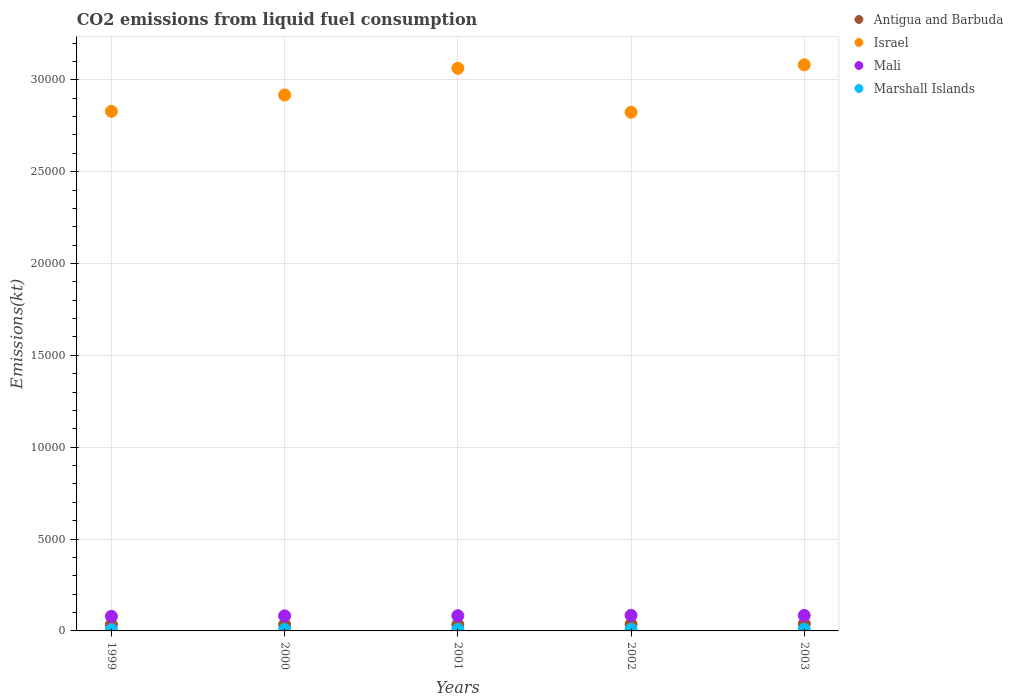Is the number of dotlines equal to the number of legend labels?
Provide a short and direct response. Yes. What is the amount of CO2 emitted in Antigua and Barbuda in 2000?
Keep it short and to the point. 344.7. Across all years, what is the maximum amount of CO2 emitted in Israel?
Your answer should be compact. 3.08e+04. Across all years, what is the minimum amount of CO2 emitted in Marshall Islands?
Make the answer very short. 66.01. In which year was the amount of CO2 emitted in Israel maximum?
Provide a succinct answer. 2003. In which year was the amount of CO2 emitted in Mali minimum?
Make the answer very short. 1999. What is the total amount of CO2 emitted in Antigua and Barbuda in the graph?
Keep it short and to the point. 1789.5. What is the difference between the amount of CO2 emitted in Antigua and Barbuda in 1999 and that in 2000?
Keep it short and to the point. 3.67. What is the difference between the amount of CO2 emitted in Mali in 2003 and the amount of CO2 emitted in Antigua and Barbuda in 2000?
Offer a very short reply. 498.71. What is the average amount of CO2 emitted in Antigua and Barbuda per year?
Provide a succinct answer. 357.9. In the year 2003, what is the difference between the amount of CO2 emitted in Israel and amount of CO2 emitted in Marshall Islands?
Give a very brief answer. 3.07e+04. In how many years, is the amount of CO2 emitted in Antigua and Barbuda greater than 15000 kt?
Give a very brief answer. 0. What is the ratio of the amount of CO2 emitted in Antigua and Barbuda in 1999 to that in 2002?
Give a very brief answer. 0.96. What is the difference between the highest and the second highest amount of CO2 emitted in Marshall Islands?
Your response must be concise. 0. What is the difference between the highest and the lowest amount of CO2 emitted in Antigua and Barbuda?
Give a very brief answer. 44. In how many years, is the amount of CO2 emitted in Mali greater than the average amount of CO2 emitted in Mali taken over all years?
Provide a short and direct response. 3. Is the sum of the amount of CO2 emitted in Mali in 1999 and 2003 greater than the maximum amount of CO2 emitted in Marshall Islands across all years?
Make the answer very short. Yes. Is it the case that in every year, the sum of the amount of CO2 emitted in Marshall Islands and amount of CO2 emitted in Antigua and Barbuda  is greater than the amount of CO2 emitted in Mali?
Offer a terse response. No. Is the amount of CO2 emitted in Mali strictly greater than the amount of CO2 emitted in Marshall Islands over the years?
Make the answer very short. Yes. Is the amount of CO2 emitted in Antigua and Barbuda strictly less than the amount of CO2 emitted in Marshall Islands over the years?
Make the answer very short. No. How many dotlines are there?
Provide a succinct answer. 4. Does the graph contain grids?
Offer a terse response. Yes. Where does the legend appear in the graph?
Ensure brevity in your answer.  Top right. How many legend labels are there?
Provide a short and direct response. 4. What is the title of the graph?
Offer a very short reply. CO2 emissions from liquid fuel consumption. Does "Cabo Verde" appear as one of the legend labels in the graph?
Offer a very short reply. No. What is the label or title of the Y-axis?
Make the answer very short. Emissions(kt). What is the Emissions(kt) of Antigua and Barbuda in 1999?
Offer a terse response. 348.37. What is the Emissions(kt) of Israel in 1999?
Your answer should be very brief. 2.83e+04. What is the Emissions(kt) of Mali in 1999?
Provide a short and direct response. 795.74. What is the Emissions(kt) of Marshall Islands in 1999?
Offer a terse response. 66.01. What is the Emissions(kt) in Antigua and Barbuda in 2000?
Offer a very short reply. 344.7. What is the Emissions(kt) in Israel in 2000?
Ensure brevity in your answer.  2.92e+04. What is the Emissions(kt) of Mali in 2000?
Provide a short and direct response. 821.41. What is the Emissions(kt) of Marshall Islands in 2000?
Keep it short and to the point. 77.01. What is the Emissions(kt) in Antigua and Barbuda in 2001?
Ensure brevity in your answer.  344.7. What is the Emissions(kt) of Israel in 2001?
Keep it short and to the point. 3.06e+04. What is the Emissions(kt) in Mali in 2001?
Offer a very short reply. 828.74. What is the Emissions(kt) in Marshall Islands in 2001?
Ensure brevity in your answer.  80.67. What is the Emissions(kt) in Antigua and Barbuda in 2002?
Your answer should be compact. 363.03. What is the Emissions(kt) of Israel in 2002?
Ensure brevity in your answer.  2.82e+04. What is the Emissions(kt) in Mali in 2002?
Ensure brevity in your answer.  847.08. What is the Emissions(kt) of Marshall Islands in 2002?
Provide a succinct answer. 84.34. What is the Emissions(kt) in Antigua and Barbuda in 2003?
Your response must be concise. 388.7. What is the Emissions(kt) in Israel in 2003?
Keep it short and to the point. 3.08e+04. What is the Emissions(kt) in Mali in 2003?
Ensure brevity in your answer.  843.41. What is the Emissions(kt) of Marshall Islands in 2003?
Give a very brief answer. 84.34. Across all years, what is the maximum Emissions(kt) in Antigua and Barbuda?
Provide a succinct answer. 388.7. Across all years, what is the maximum Emissions(kt) of Israel?
Provide a short and direct response. 3.08e+04. Across all years, what is the maximum Emissions(kt) in Mali?
Your answer should be compact. 847.08. Across all years, what is the maximum Emissions(kt) in Marshall Islands?
Make the answer very short. 84.34. Across all years, what is the minimum Emissions(kt) in Antigua and Barbuda?
Provide a short and direct response. 344.7. Across all years, what is the minimum Emissions(kt) in Israel?
Make the answer very short. 2.82e+04. Across all years, what is the minimum Emissions(kt) of Mali?
Offer a very short reply. 795.74. Across all years, what is the minimum Emissions(kt) in Marshall Islands?
Offer a terse response. 66.01. What is the total Emissions(kt) of Antigua and Barbuda in the graph?
Ensure brevity in your answer.  1789.5. What is the total Emissions(kt) of Israel in the graph?
Your answer should be compact. 1.47e+05. What is the total Emissions(kt) in Mali in the graph?
Offer a very short reply. 4136.38. What is the total Emissions(kt) of Marshall Islands in the graph?
Give a very brief answer. 392.37. What is the difference between the Emissions(kt) in Antigua and Barbuda in 1999 and that in 2000?
Give a very brief answer. 3.67. What is the difference between the Emissions(kt) of Israel in 1999 and that in 2000?
Ensure brevity in your answer.  -891.08. What is the difference between the Emissions(kt) of Mali in 1999 and that in 2000?
Your answer should be compact. -25.67. What is the difference between the Emissions(kt) in Marshall Islands in 1999 and that in 2000?
Provide a short and direct response. -11. What is the difference between the Emissions(kt) in Antigua and Barbuda in 1999 and that in 2001?
Offer a terse response. 3.67. What is the difference between the Emissions(kt) in Israel in 1999 and that in 2001?
Offer a terse response. -2346.88. What is the difference between the Emissions(kt) of Mali in 1999 and that in 2001?
Give a very brief answer. -33. What is the difference between the Emissions(kt) in Marshall Islands in 1999 and that in 2001?
Give a very brief answer. -14.67. What is the difference between the Emissions(kt) of Antigua and Barbuda in 1999 and that in 2002?
Offer a very short reply. -14.67. What is the difference between the Emissions(kt) of Israel in 1999 and that in 2002?
Make the answer very short. 47.67. What is the difference between the Emissions(kt) of Mali in 1999 and that in 2002?
Your answer should be very brief. -51.34. What is the difference between the Emissions(kt) in Marshall Islands in 1999 and that in 2002?
Keep it short and to the point. -18.34. What is the difference between the Emissions(kt) of Antigua and Barbuda in 1999 and that in 2003?
Your response must be concise. -40.34. What is the difference between the Emissions(kt) in Israel in 1999 and that in 2003?
Give a very brief answer. -2533.9. What is the difference between the Emissions(kt) of Mali in 1999 and that in 2003?
Provide a short and direct response. -47.67. What is the difference between the Emissions(kt) in Marshall Islands in 1999 and that in 2003?
Give a very brief answer. -18.34. What is the difference between the Emissions(kt) in Antigua and Barbuda in 2000 and that in 2001?
Give a very brief answer. 0. What is the difference between the Emissions(kt) in Israel in 2000 and that in 2001?
Your answer should be compact. -1455.8. What is the difference between the Emissions(kt) of Mali in 2000 and that in 2001?
Ensure brevity in your answer.  -7.33. What is the difference between the Emissions(kt) of Marshall Islands in 2000 and that in 2001?
Keep it short and to the point. -3.67. What is the difference between the Emissions(kt) in Antigua and Barbuda in 2000 and that in 2002?
Offer a terse response. -18.34. What is the difference between the Emissions(kt) of Israel in 2000 and that in 2002?
Offer a very short reply. 938.75. What is the difference between the Emissions(kt) of Mali in 2000 and that in 2002?
Offer a terse response. -25.67. What is the difference between the Emissions(kt) in Marshall Islands in 2000 and that in 2002?
Keep it short and to the point. -7.33. What is the difference between the Emissions(kt) in Antigua and Barbuda in 2000 and that in 2003?
Keep it short and to the point. -44. What is the difference between the Emissions(kt) of Israel in 2000 and that in 2003?
Provide a succinct answer. -1642.82. What is the difference between the Emissions(kt) in Mali in 2000 and that in 2003?
Make the answer very short. -22. What is the difference between the Emissions(kt) in Marshall Islands in 2000 and that in 2003?
Give a very brief answer. -7.33. What is the difference between the Emissions(kt) of Antigua and Barbuda in 2001 and that in 2002?
Offer a terse response. -18.34. What is the difference between the Emissions(kt) of Israel in 2001 and that in 2002?
Give a very brief answer. 2394.55. What is the difference between the Emissions(kt) in Mali in 2001 and that in 2002?
Give a very brief answer. -18.34. What is the difference between the Emissions(kt) of Marshall Islands in 2001 and that in 2002?
Ensure brevity in your answer.  -3.67. What is the difference between the Emissions(kt) in Antigua and Barbuda in 2001 and that in 2003?
Offer a terse response. -44. What is the difference between the Emissions(kt) in Israel in 2001 and that in 2003?
Give a very brief answer. -187.02. What is the difference between the Emissions(kt) of Mali in 2001 and that in 2003?
Make the answer very short. -14.67. What is the difference between the Emissions(kt) of Marshall Islands in 2001 and that in 2003?
Provide a short and direct response. -3.67. What is the difference between the Emissions(kt) in Antigua and Barbuda in 2002 and that in 2003?
Keep it short and to the point. -25.67. What is the difference between the Emissions(kt) of Israel in 2002 and that in 2003?
Ensure brevity in your answer.  -2581.57. What is the difference between the Emissions(kt) in Mali in 2002 and that in 2003?
Your response must be concise. 3.67. What is the difference between the Emissions(kt) in Antigua and Barbuda in 1999 and the Emissions(kt) in Israel in 2000?
Offer a very short reply. -2.88e+04. What is the difference between the Emissions(kt) of Antigua and Barbuda in 1999 and the Emissions(kt) of Mali in 2000?
Make the answer very short. -473.04. What is the difference between the Emissions(kt) in Antigua and Barbuda in 1999 and the Emissions(kt) in Marshall Islands in 2000?
Offer a very short reply. 271.36. What is the difference between the Emissions(kt) of Israel in 1999 and the Emissions(kt) of Mali in 2000?
Offer a terse response. 2.75e+04. What is the difference between the Emissions(kt) of Israel in 1999 and the Emissions(kt) of Marshall Islands in 2000?
Offer a very short reply. 2.82e+04. What is the difference between the Emissions(kt) in Mali in 1999 and the Emissions(kt) in Marshall Islands in 2000?
Keep it short and to the point. 718.73. What is the difference between the Emissions(kt) in Antigua and Barbuda in 1999 and the Emissions(kt) in Israel in 2001?
Give a very brief answer. -3.03e+04. What is the difference between the Emissions(kt) of Antigua and Barbuda in 1999 and the Emissions(kt) of Mali in 2001?
Offer a terse response. -480.38. What is the difference between the Emissions(kt) of Antigua and Barbuda in 1999 and the Emissions(kt) of Marshall Islands in 2001?
Make the answer very short. 267.69. What is the difference between the Emissions(kt) in Israel in 1999 and the Emissions(kt) in Mali in 2001?
Provide a short and direct response. 2.75e+04. What is the difference between the Emissions(kt) of Israel in 1999 and the Emissions(kt) of Marshall Islands in 2001?
Your response must be concise. 2.82e+04. What is the difference between the Emissions(kt) in Mali in 1999 and the Emissions(kt) in Marshall Islands in 2001?
Offer a terse response. 715.07. What is the difference between the Emissions(kt) of Antigua and Barbuda in 1999 and the Emissions(kt) of Israel in 2002?
Make the answer very short. -2.79e+04. What is the difference between the Emissions(kt) of Antigua and Barbuda in 1999 and the Emissions(kt) of Mali in 2002?
Give a very brief answer. -498.71. What is the difference between the Emissions(kt) in Antigua and Barbuda in 1999 and the Emissions(kt) in Marshall Islands in 2002?
Provide a short and direct response. 264.02. What is the difference between the Emissions(kt) of Israel in 1999 and the Emissions(kt) of Mali in 2002?
Offer a terse response. 2.74e+04. What is the difference between the Emissions(kt) in Israel in 1999 and the Emissions(kt) in Marshall Islands in 2002?
Offer a terse response. 2.82e+04. What is the difference between the Emissions(kt) in Mali in 1999 and the Emissions(kt) in Marshall Islands in 2002?
Keep it short and to the point. 711.4. What is the difference between the Emissions(kt) of Antigua and Barbuda in 1999 and the Emissions(kt) of Israel in 2003?
Make the answer very short. -3.05e+04. What is the difference between the Emissions(kt) in Antigua and Barbuda in 1999 and the Emissions(kt) in Mali in 2003?
Your answer should be compact. -495.05. What is the difference between the Emissions(kt) in Antigua and Barbuda in 1999 and the Emissions(kt) in Marshall Islands in 2003?
Keep it short and to the point. 264.02. What is the difference between the Emissions(kt) of Israel in 1999 and the Emissions(kt) of Mali in 2003?
Offer a terse response. 2.74e+04. What is the difference between the Emissions(kt) in Israel in 1999 and the Emissions(kt) in Marshall Islands in 2003?
Ensure brevity in your answer.  2.82e+04. What is the difference between the Emissions(kt) in Mali in 1999 and the Emissions(kt) in Marshall Islands in 2003?
Make the answer very short. 711.4. What is the difference between the Emissions(kt) of Antigua and Barbuda in 2000 and the Emissions(kt) of Israel in 2001?
Offer a terse response. -3.03e+04. What is the difference between the Emissions(kt) of Antigua and Barbuda in 2000 and the Emissions(kt) of Mali in 2001?
Provide a short and direct response. -484.04. What is the difference between the Emissions(kt) in Antigua and Barbuda in 2000 and the Emissions(kt) in Marshall Islands in 2001?
Ensure brevity in your answer.  264.02. What is the difference between the Emissions(kt) in Israel in 2000 and the Emissions(kt) in Mali in 2001?
Provide a short and direct response. 2.83e+04. What is the difference between the Emissions(kt) of Israel in 2000 and the Emissions(kt) of Marshall Islands in 2001?
Your response must be concise. 2.91e+04. What is the difference between the Emissions(kt) of Mali in 2000 and the Emissions(kt) of Marshall Islands in 2001?
Offer a very short reply. 740.73. What is the difference between the Emissions(kt) of Antigua and Barbuda in 2000 and the Emissions(kt) of Israel in 2002?
Provide a succinct answer. -2.79e+04. What is the difference between the Emissions(kt) of Antigua and Barbuda in 2000 and the Emissions(kt) of Mali in 2002?
Ensure brevity in your answer.  -502.38. What is the difference between the Emissions(kt) in Antigua and Barbuda in 2000 and the Emissions(kt) in Marshall Islands in 2002?
Keep it short and to the point. 260.36. What is the difference between the Emissions(kt) of Israel in 2000 and the Emissions(kt) of Mali in 2002?
Offer a terse response. 2.83e+04. What is the difference between the Emissions(kt) of Israel in 2000 and the Emissions(kt) of Marshall Islands in 2002?
Provide a short and direct response. 2.91e+04. What is the difference between the Emissions(kt) in Mali in 2000 and the Emissions(kt) in Marshall Islands in 2002?
Your response must be concise. 737.07. What is the difference between the Emissions(kt) of Antigua and Barbuda in 2000 and the Emissions(kt) of Israel in 2003?
Make the answer very short. -3.05e+04. What is the difference between the Emissions(kt) in Antigua and Barbuda in 2000 and the Emissions(kt) in Mali in 2003?
Ensure brevity in your answer.  -498.71. What is the difference between the Emissions(kt) of Antigua and Barbuda in 2000 and the Emissions(kt) of Marshall Islands in 2003?
Your answer should be very brief. 260.36. What is the difference between the Emissions(kt) in Israel in 2000 and the Emissions(kt) in Mali in 2003?
Your response must be concise. 2.83e+04. What is the difference between the Emissions(kt) of Israel in 2000 and the Emissions(kt) of Marshall Islands in 2003?
Make the answer very short. 2.91e+04. What is the difference between the Emissions(kt) of Mali in 2000 and the Emissions(kt) of Marshall Islands in 2003?
Keep it short and to the point. 737.07. What is the difference between the Emissions(kt) of Antigua and Barbuda in 2001 and the Emissions(kt) of Israel in 2002?
Offer a very short reply. -2.79e+04. What is the difference between the Emissions(kt) of Antigua and Barbuda in 2001 and the Emissions(kt) of Mali in 2002?
Provide a short and direct response. -502.38. What is the difference between the Emissions(kt) in Antigua and Barbuda in 2001 and the Emissions(kt) in Marshall Islands in 2002?
Provide a short and direct response. 260.36. What is the difference between the Emissions(kt) of Israel in 2001 and the Emissions(kt) of Mali in 2002?
Keep it short and to the point. 2.98e+04. What is the difference between the Emissions(kt) in Israel in 2001 and the Emissions(kt) in Marshall Islands in 2002?
Offer a terse response. 3.05e+04. What is the difference between the Emissions(kt) of Mali in 2001 and the Emissions(kt) of Marshall Islands in 2002?
Your answer should be very brief. 744.4. What is the difference between the Emissions(kt) of Antigua and Barbuda in 2001 and the Emissions(kt) of Israel in 2003?
Provide a succinct answer. -3.05e+04. What is the difference between the Emissions(kt) in Antigua and Barbuda in 2001 and the Emissions(kt) in Mali in 2003?
Provide a succinct answer. -498.71. What is the difference between the Emissions(kt) of Antigua and Barbuda in 2001 and the Emissions(kt) of Marshall Islands in 2003?
Ensure brevity in your answer.  260.36. What is the difference between the Emissions(kt) of Israel in 2001 and the Emissions(kt) of Mali in 2003?
Your answer should be very brief. 2.98e+04. What is the difference between the Emissions(kt) in Israel in 2001 and the Emissions(kt) in Marshall Islands in 2003?
Your response must be concise. 3.05e+04. What is the difference between the Emissions(kt) in Mali in 2001 and the Emissions(kt) in Marshall Islands in 2003?
Give a very brief answer. 744.4. What is the difference between the Emissions(kt) in Antigua and Barbuda in 2002 and the Emissions(kt) in Israel in 2003?
Ensure brevity in your answer.  -3.05e+04. What is the difference between the Emissions(kt) of Antigua and Barbuda in 2002 and the Emissions(kt) of Mali in 2003?
Keep it short and to the point. -480.38. What is the difference between the Emissions(kt) of Antigua and Barbuda in 2002 and the Emissions(kt) of Marshall Islands in 2003?
Give a very brief answer. 278.69. What is the difference between the Emissions(kt) of Israel in 2002 and the Emissions(kt) of Mali in 2003?
Offer a very short reply. 2.74e+04. What is the difference between the Emissions(kt) in Israel in 2002 and the Emissions(kt) in Marshall Islands in 2003?
Provide a succinct answer. 2.81e+04. What is the difference between the Emissions(kt) of Mali in 2002 and the Emissions(kt) of Marshall Islands in 2003?
Offer a terse response. 762.74. What is the average Emissions(kt) of Antigua and Barbuda per year?
Your answer should be very brief. 357.9. What is the average Emissions(kt) of Israel per year?
Your answer should be very brief. 2.94e+04. What is the average Emissions(kt) of Mali per year?
Offer a terse response. 827.28. What is the average Emissions(kt) in Marshall Islands per year?
Your response must be concise. 78.47. In the year 1999, what is the difference between the Emissions(kt) of Antigua and Barbuda and Emissions(kt) of Israel?
Make the answer very short. -2.79e+04. In the year 1999, what is the difference between the Emissions(kt) of Antigua and Barbuda and Emissions(kt) of Mali?
Provide a succinct answer. -447.37. In the year 1999, what is the difference between the Emissions(kt) of Antigua and Barbuda and Emissions(kt) of Marshall Islands?
Give a very brief answer. 282.36. In the year 1999, what is the difference between the Emissions(kt) of Israel and Emissions(kt) of Mali?
Ensure brevity in your answer.  2.75e+04. In the year 1999, what is the difference between the Emissions(kt) of Israel and Emissions(kt) of Marshall Islands?
Your answer should be compact. 2.82e+04. In the year 1999, what is the difference between the Emissions(kt) of Mali and Emissions(kt) of Marshall Islands?
Make the answer very short. 729.73. In the year 2000, what is the difference between the Emissions(kt) of Antigua and Barbuda and Emissions(kt) of Israel?
Provide a succinct answer. -2.88e+04. In the year 2000, what is the difference between the Emissions(kt) in Antigua and Barbuda and Emissions(kt) in Mali?
Provide a short and direct response. -476.71. In the year 2000, what is the difference between the Emissions(kt) of Antigua and Barbuda and Emissions(kt) of Marshall Islands?
Your answer should be very brief. 267.69. In the year 2000, what is the difference between the Emissions(kt) in Israel and Emissions(kt) in Mali?
Give a very brief answer. 2.83e+04. In the year 2000, what is the difference between the Emissions(kt) in Israel and Emissions(kt) in Marshall Islands?
Keep it short and to the point. 2.91e+04. In the year 2000, what is the difference between the Emissions(kt) of Mali and Emissions(kt) of Marshall Islands?
Provide a succinct answer. 744.4. In the year 2001, what is the difference between the Emissions(kt) of Antigua and Barbuda and Emissions(kt) of Israel?
Offer a very short reply. -3.03e+04. In the year 2001, what is the difference between the Emissions(kt) in Antigua and Barbuda and Emissions(kt) in Mali?
Offer a terse response. -484.04. In the year 2001, what is the difference between the Emissions(kt) in Antigua and Barbuda and Emissions(kt) in Marshall Islands?
Make the answer very short. 264.02. In the year 2001, what is the difference between the Emissions(kt) of Israel and Emissions(kt) of Mali?
Keep it short and to the point. 2.98e+04. In the year 2001, what is the difference between the Emissions(kt) of Israel and Emissions(kt) of Marshall Islands?
Offer a very short reply. 3.05e+04. In the year 2001, what is the difference between the Emissions(kt) in Mali and Emissions(kt) in Marshall Islands?
Your response must be concise. 748.07. In the year 2002, what is the difference between the Emissions(kt) of Antigua and Barbuda and Emissions(kt) of Israel?
Give a very brief answer. -2.79e+04. In the year 2002, what is the difference between the Emissions(kt) in Antigua and Barbuda and Emissions(kt) in Mali?
Keep it short and to the point. -484.04. In the year 2002, what is the difference between the Emissions(kt) in Antigua and Barbuda and Emissions(kt) in Marshall Islands?
Offer a terse response. 278.69. In the year 2002, what is the difference between the Emissions(kt) in Israel and Emissions(kt) in Mali?
Provide a short and direct response. 2.74e+04. In the year 2002, what is the difference between the Emissions(kt) of Israel and Emissions(kt) of Marshall Islands?
Your response must be concise. 2.81e+04. In the year 2002, what is the difference between the Emissions(kt) of Mali and Emissions(kt) of Marshall Islands?
Ensure brevity in your answer.  762.74. In the year 2003, what is the difference between the Emissions(kt) in Antigua and Barbuda and Emissions(kt) in Israel?
Give a very brief answer. -3.04e+04. In the year 2003, what is the difference between the Emissions(kt) in Antigua and Barbuda and Emissions(kt) in Mali?
Offer a very short reply. -454.71. In the year 2003, what is the difference between the Emissions(kt) in Antigua and Barbuda and Emissions(kt) in Marshall Islands?
Your response must be concise. 304.36. In the year 2003, what is the difference between the Emissions(kt) of Israel and Emissions(kt) of Mali?
Make the answer very short. 3.00e+04. In the year 2003, what is the difference between the Emissions(kt) in Israel and Emissions(kt) in Marshall Islands?
Provide a succinct answer. 3.07e+04. In the year 2003, what is the difference between the Emissions(kt) of Mali and Emissions(kt) of Marshall Islands?
Provide a short and direct response. 759.07. What is the ratio of the Emissions(kt) of Antigua and Barbuda in 1999 to that in 2000?
Offer a terse response. 1.01. What is the ratio of the Emissions(kt) of Israel in 1999 to that in 2000?
Your response must be concise. 0.97. What is the ratio of the Emissions(kt) of Mali in 1999 to that in 2000?
Keep it short and to the point. 0.97. What is the ratio of the Emissions(kt) of Marshall Islands in 1999 to that in 2000?
Make the answer very short. 0.86. What is the ratio of the Emissions(kt) of Antigua and Barbuda in 1999 to that in 2001?
Give a very brief answer. 1.01. What is the ratio of the Emissions(kt) of Israel in 1999 to that in 2001?
Keep it short and to the point. 0.92. What is the ratio of the Emissions(kt) in Mali in 1999 to that in 2001?
Your answer should be very brief. 0.96. What is the ratio of the Emissions(kt) of Marshall Islands in 1999 to that in 2001?
Your answer should be compact. 0.82. What is the ratio of the Emissions(kt) in Antigua and Barbuda in 1999 to that in 2002?
Your response must be concise. 0.96. What is the ratio of the Emissions(kt) in Mali in 1999 to that in 2002?
Make the answer very short. 0.94. What is the ratio of the Emissions(kt) in Marshall Islands in 1999 to that in 2002?
Ensure brevity in your answer.  0.78. What is the ratio of the Emissions(kt) in Antigua and Barbuda in 1999 to that in 2003?
Your answer should be very brief. 0.9. What is the ratio of the Emissions(kt) of Israel in 1999 to that in 2003?
Offer a terse response. 0.92. What is the ratio of the Emissions(kt) of Mali in 1999 to that in 2003?
Keep it short and to the point. 0.94. What is the ratio of the Emissions(kt) in Marshall Islands in 1999 to that in 2003?
Make the answer very short. 0.78. What is the ratio of the Emissions(kt) in Israel in 2000 to that in 2001?
Your answer should be very brief. 0.95. What is the ratio of the Emissions(kt) in Mali in 2000 to that in 2001?
Provide a short and direct response. 0.99. What is the ratio of the Emissions(kt) in Marshall Islands in 2000 to that in 2001?
Offer a terse response. 0.95. What is the ratio of the Emissions(kt) in Antigua and Barbuda in 2000 to that in 2002?
Your answer should be compact. 0.95. What is the ratio of the Emissions(kt) of Mali in 2000 to that in 2002?
Give a very brief answer. 0.97. What is the ratio of the Emissions(kt) of Marshall Islands in 2000 to that in 2002?
Offer a very short reply. 0.91. What is the ratio of the Emissions(kt) of Antigua and Barbuda in 2000 to that in 2003?
Make the answer very short. 0.89. What is the ratio of the Emissions(kt) of Israel in 2000 to that in 2003?
Offer a terse response. 0.95. What is the ratio of the Emissions(kt) of Mali in 2000 to that in 2003?
Offer a very short reply. 0.97. What is the ratio of the Emissions(kt) in Marshall Islands in 2000 to that in 2003?
Keep it short and to the point. 0.91. What is the ratio of the Emissions(kt) of Antigua and Barbuda in 2001 to that in 2002?
Provide a succinct answer. 0.95. What is the ratio of the Emissions(kt) of Israel in 2001 to that in 2002?
Keep it short and to the point. 1.08. What is the ratio of the Emissions(kt) of Mali in 2001 to that in 2002?
Offer a very short reply. 0.98. What is the ratio of the Emissions(kt) of Marshall Islands in 2001 to that in 2002?
Your response must be concise. 0.96. What is the ratio of the Emissions(kt) of Antigua and Barbuda in 2001 to that in 2003?
Offer a terse response. 0.89. What is the ratio of the Emissions(kt) in Mali in 2001 to that in 2003?
Your answer should be compact. 0.98. What is the ratio of the Emissions(kt) in Marshall Islands in 2001 to that in 2003?
Ensure brevity in your answer.  0.96. What is the ratio of the Emissions(kt) of Antigua and Barbuda in 2002 to that in 2003?
Your answer should be very brief. 0.93. What is the ratio of the Emissions(kt) in Israel in 2002 to that in 2003?
Offer a terse response. 0.92. What is the ratio of the Emissions(kt) of Mali in 2002 to that in 2003?
Your response must be concise. 1. What is the ratio of the Emissions(kt) of Marshall Islands in 2002 to that in 2003?
Offer a very short reply. 1. What is the difference between the highest and the second highest Emissions(kt) of Antigua and Barbuda?
Offer a terse response. 25.67. What is the difference between the highest and the second highest Emissions(kt) in Israel?
Give a very brief answer. 187.02. What is the difference between the highest and the second highest Emissions(kt) in Mali?
Keep it short and to the point. 3.67. What is the difference between the highest and the lowest Emissions(kt) in Antigua and Barbuda?
Your answer should be compact. 44. What is the difference between the highest and the lowest Emissions(kt) of Israel?
Offer a very short reply. 2581.57. What is the difference between the highest and the lowest Emissions(kt) in Mali?
Provide a short and direct response. 51.34. What is the difference between the highest and the lowest Emissions(kt) in Marshall Islands?
Provide a short and direct response. 18.34. 